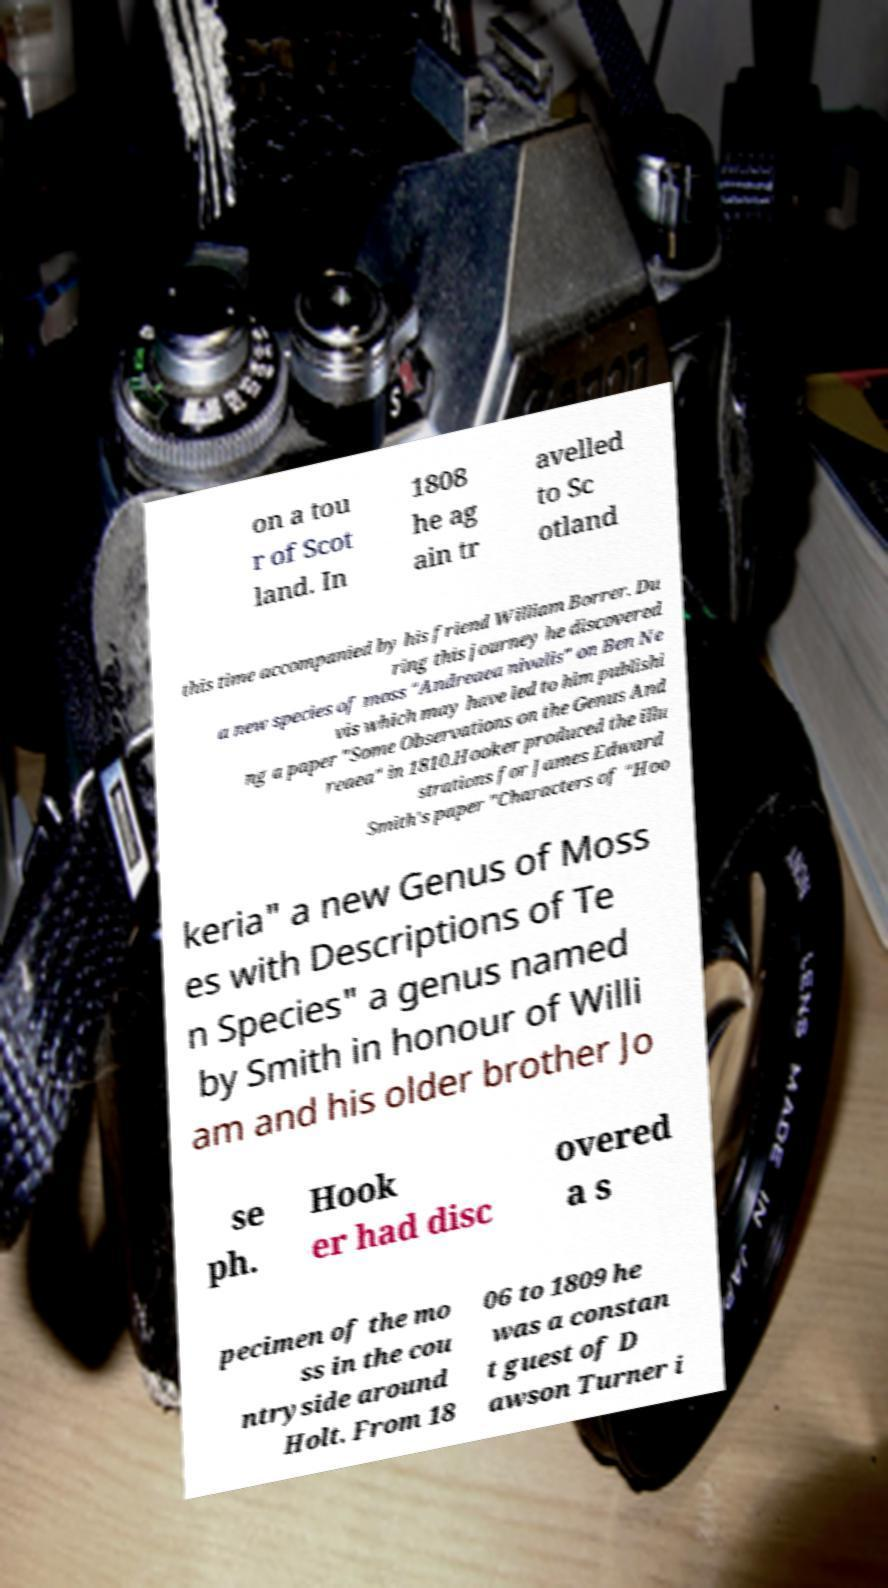There's text embedded in this image that I need extracted. Can you transcribe it verbatim? on a tou r of Scot land. In 1808 he ag ain tr avelled to Sc otland this time accompanied by his friend William Borrer. Du ring this journey he discovered a new species of moss "Andreaea nivalis" on Ben Ne vis which may have led to him publishi ng a paper "Some Observations on the Genus And reaea" in 1810.Hooker produced the illu strations for James Edward Smith's paper "Characters of "Hoo keria" a new Genus of Moss es with Descriptions of Te n Species" a genus named by Smith in honour of Willi am and his older brother Jo se ph. Hook er had disc overed a s pecimen of the mo ss in the cou ntryside around Holt. From 18 06 to 1809 he was a constan t guest of D awson Turner i 